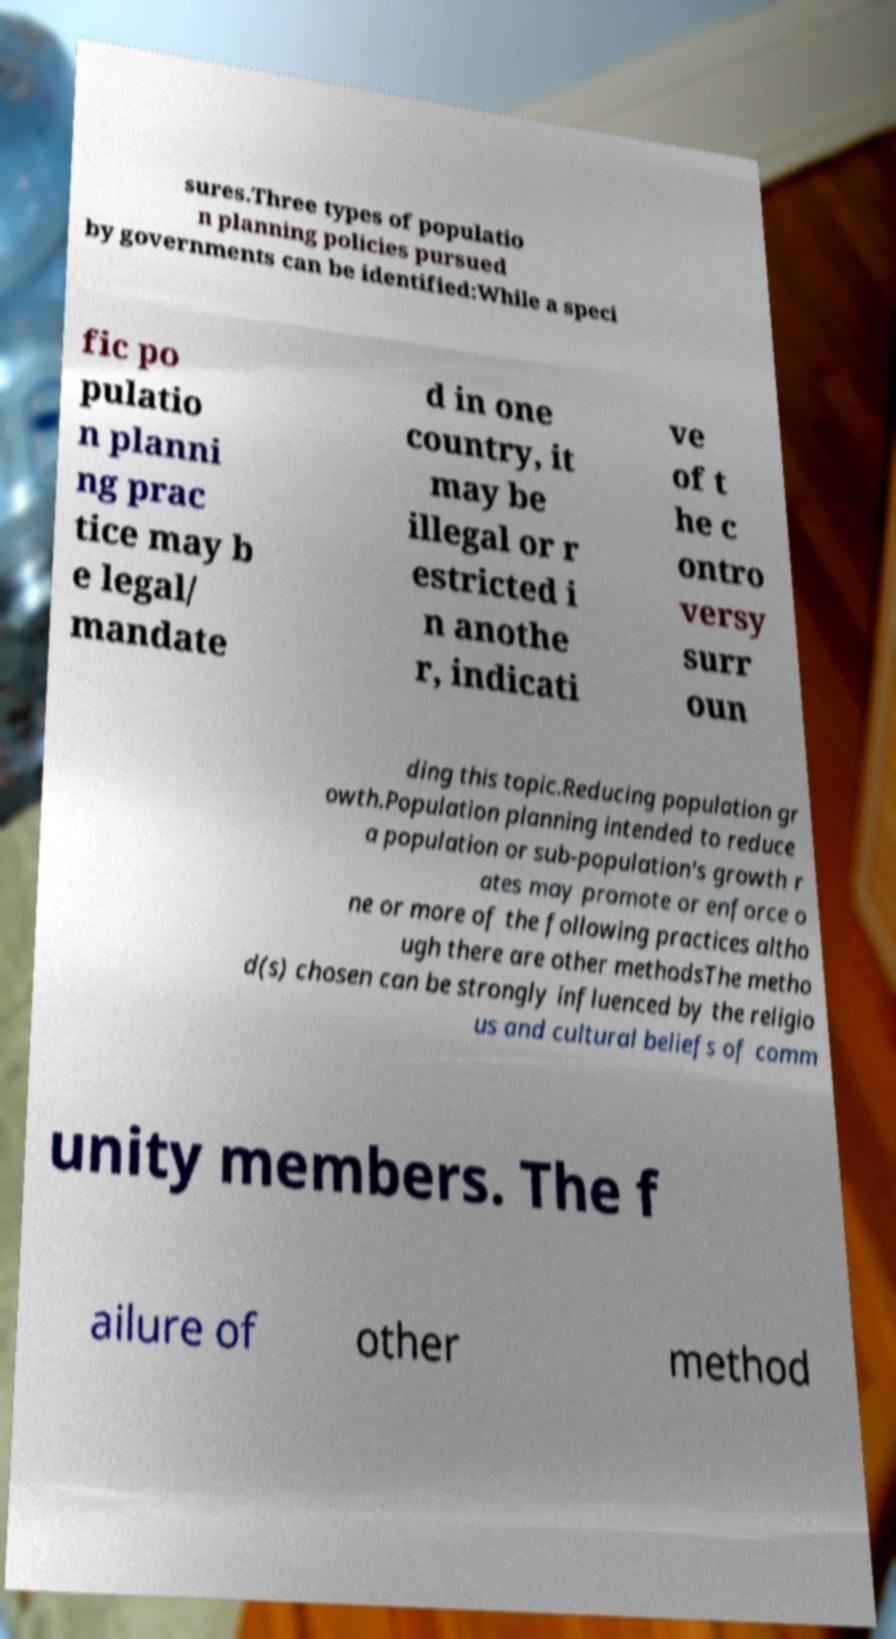Please identify and transcribe the text found in this image. sures.Three types of populatio n planning policies pursued by governments can be identified:While a speci fic po pulatio n planni ng prac tice may b e legal/ mandate d in one country, it may be illegal or r estricted i n anothe r, indicati ve of t he c ontro versy surr oun ding this topic.Reducing population gr owth.Population planning intended to reduce a population or sub-population's growth r ates may promote or enforce o ne or more of the following practices altho ugh there are other methodsThe metho d(s) chosen can be strongly influenced by the religio us and cultural beliefs of comm unity members. The f ailure of other method 